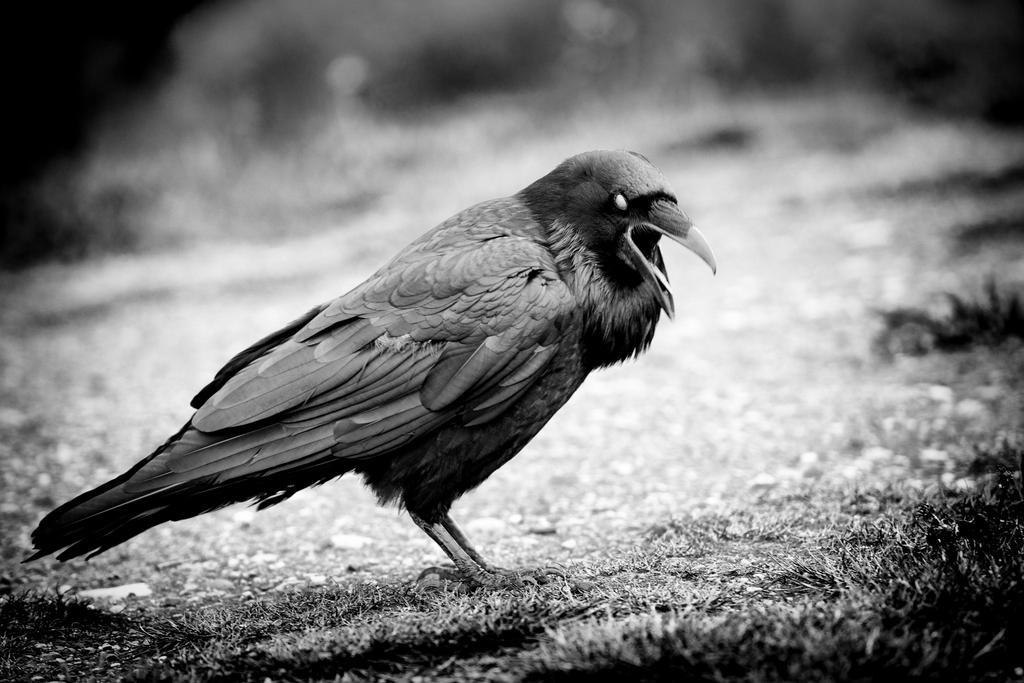What type of animal is in the image? There is a bird in the image. Where is the bird located? The bird is on the grass. Can you describe the background of the image? The background of the image is blurred. What is the color scheme of the image? The image is black and white. What is the price of the wine in the image? There is no wine present in the image, so it is not possible to determine its price. 